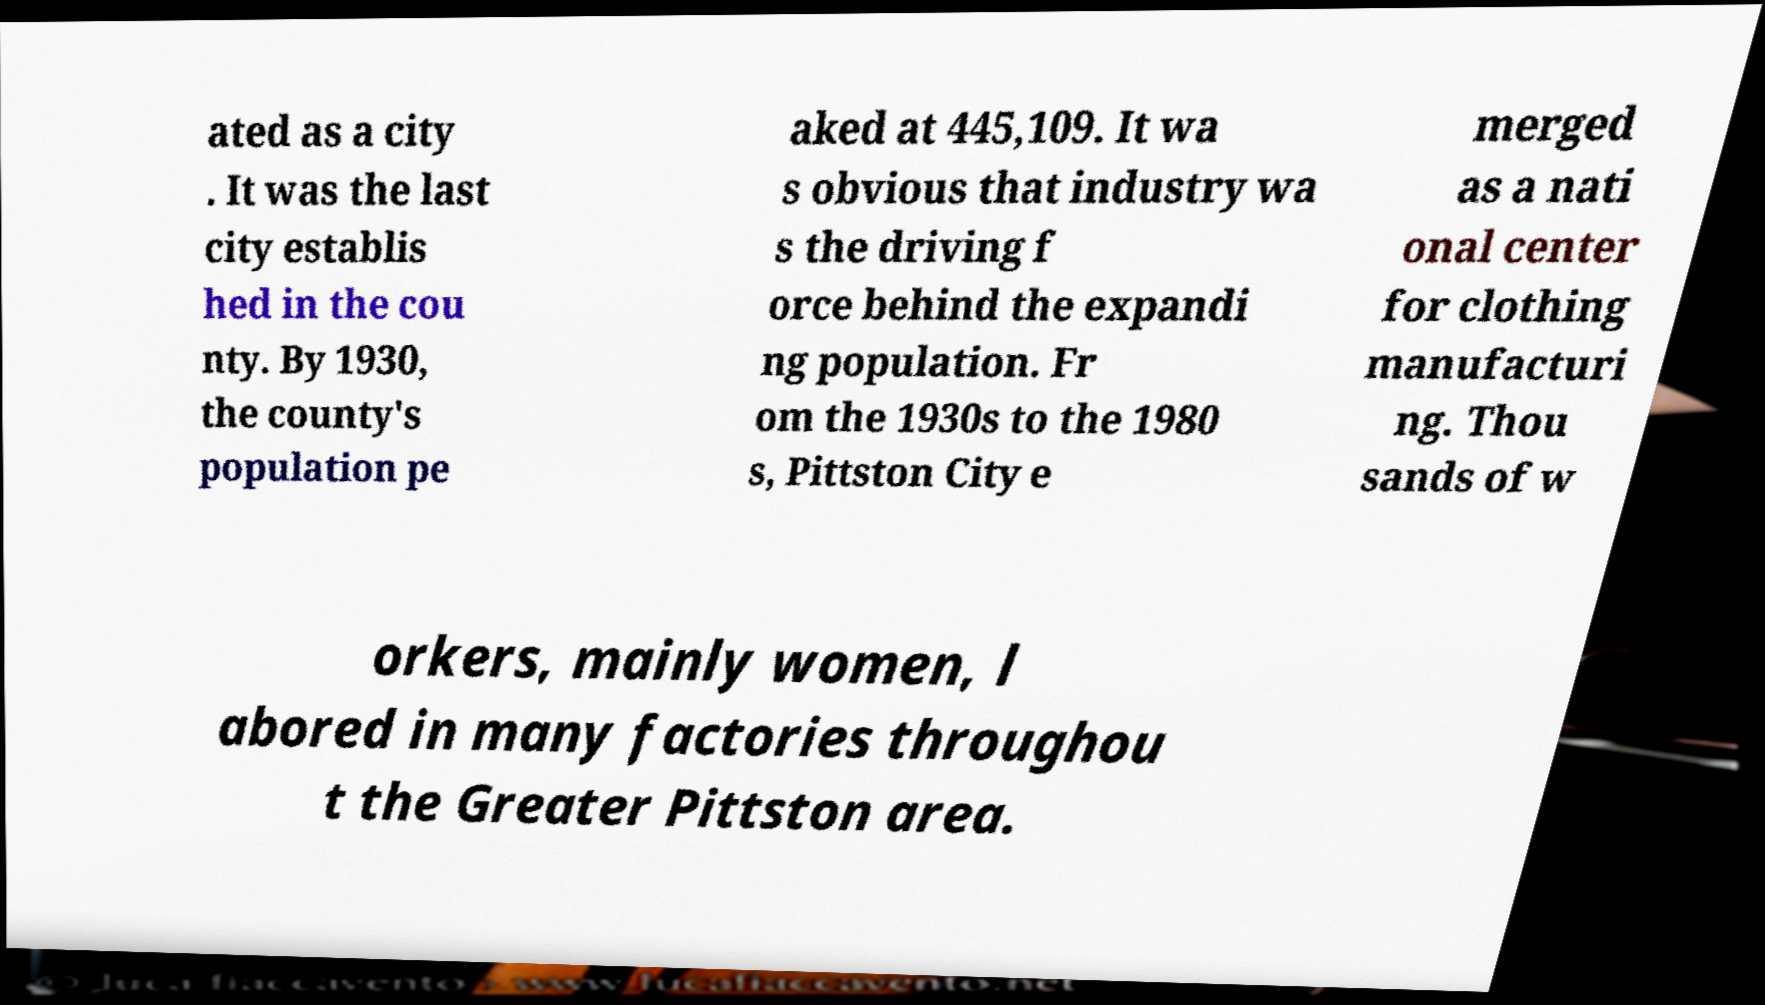Could you assist in decoding the text presented in this image and type it out clearly? ated as a city . It was the last city establis hed in the cou nty. By 1930, the county's population pe aked at 445,109. It wa s obvious that industry wa s the driving f orce behind the expandi ng population. Fr om the 1930s to the 1980 s, Pittston City e merged as a nati onal center for clothing manufacturi ng. Thou sands of w orkers, mainly women, l abored in many factories throughou t the Greater Pittston area. 